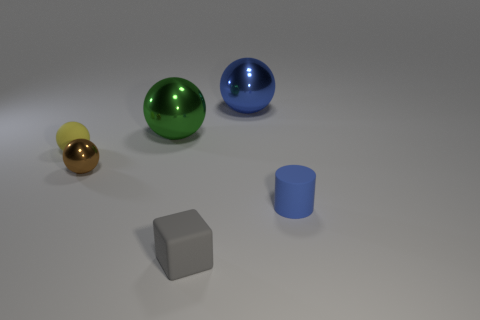Subtract all small shiny spheres. How many spheres are left? 3 Add 4 tiny gray matte blocks. How many objects exist? 10 Subtract all blue balls. How many balls are left? 3 Subtract all cylinders. How many objects are left? 5 Subtract 1 cylinders. How many cylinders are left? 0 Subtract all purple blocks. Subtract all red cylinders. How many blocks are left? 1 Subtract all large green spheres. Subtract all big things. How many objects are left? 3 Add 1 tiny objects. How many tiny objects are left? 5 Add 1 green shiny blocks. How many green shiny blocks exist? 1 Subtract 0 red cylinders. How many objects are left? 6 